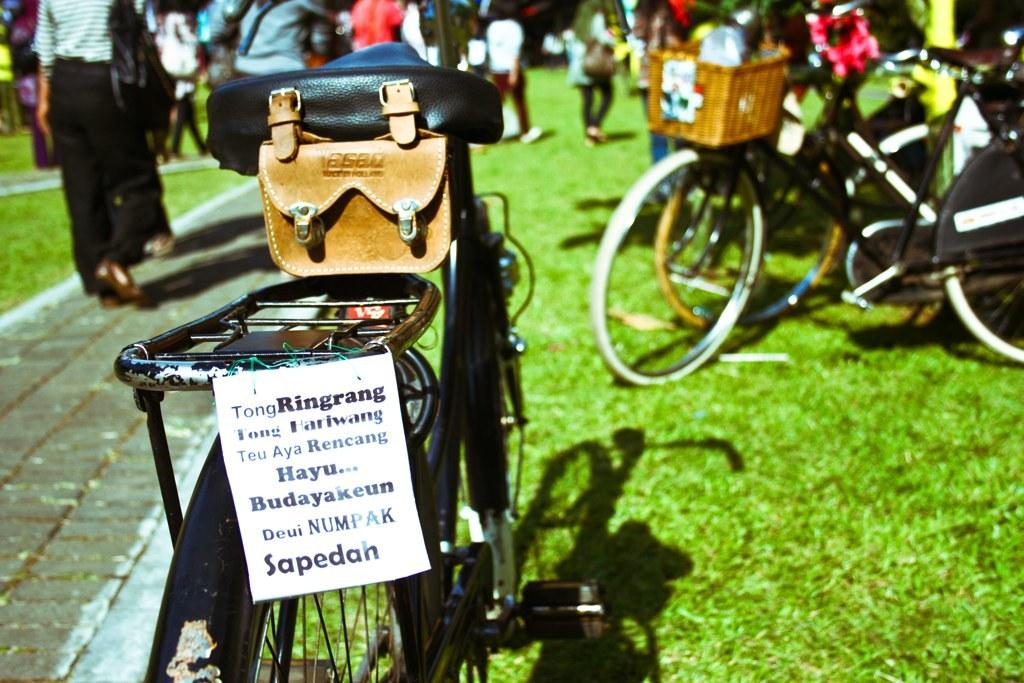What is attached to the cycle on the left side of the image? There is a paper attached to the cycle on the left side of the image. What color is the cycle? The cycle is black in color. What are the people in the image doing? The people in the image are walking. What type of vegetation is on the right side of the image? There is grass on the right side of the image. What type of horn can be seen on the cycle in the image? There is no horn present on the cycle in the image. What type of floor is visible in the image? The image does not show a floor; it shows people walking on grass. 